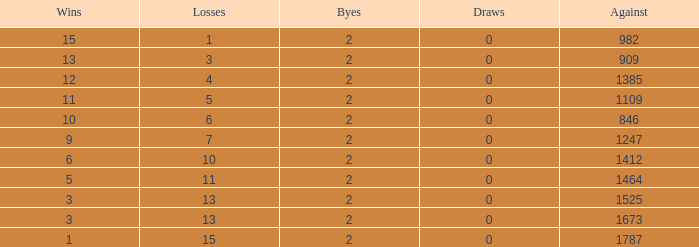What is the average number of Byes when there were less than 0 losses and were against 1247? None. 